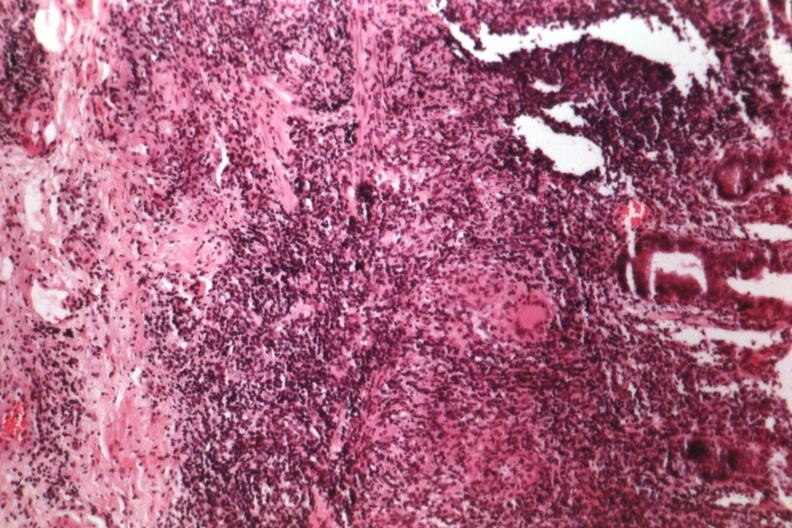s there present?
Answer the question using a single word or phrase. No 